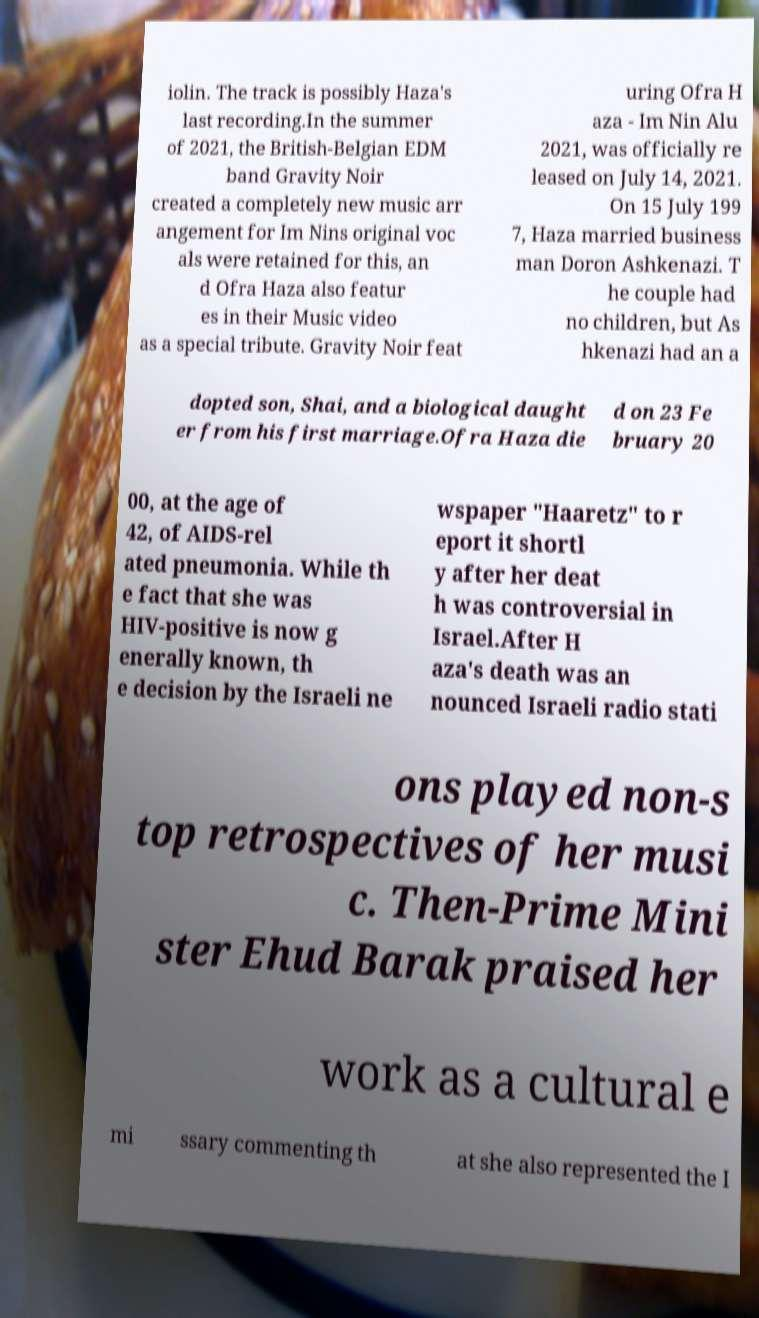What messages or text are displayed in this image? I need them in a readable, typed format. iolin. The track is possibly Haza's last recording.In the summer of 2021, the British-Belgian EDM band Gravity Noir created a completely new music arr angement for Im Nins original voc als were retained for this, an d Ofra Haza also featur es in their Music video as a special tribute. Gravity Noir feat uring Ofra H aza - Im Nin Alu 2021, was officially re leased on July 14, 2021. On 15 July 199 7, Haza married business man Doron Ashkenazi. T he couple had no children, but As hkenazi had an a dopted son, Shai, and a biological daught er from his first marriage.Ofra Haza die d on 23 Fe bruary 20 00, at the age of 42, of AIDS-rel ated pneumonia. While th e fact that she was HIV-positive is now g enerally known, th e decision by the Israeli ne wspaper "Haaretz" to r eport it shortl y after her deat h was controversial in Israel.After H aza's death was an nounced Israeli radio stati ons played non-s top retrospectives of her musi c. Then-Prime Mini ster Ehud Barak praised her work as a cultural e mi ssary commenting th at she also represented the I 